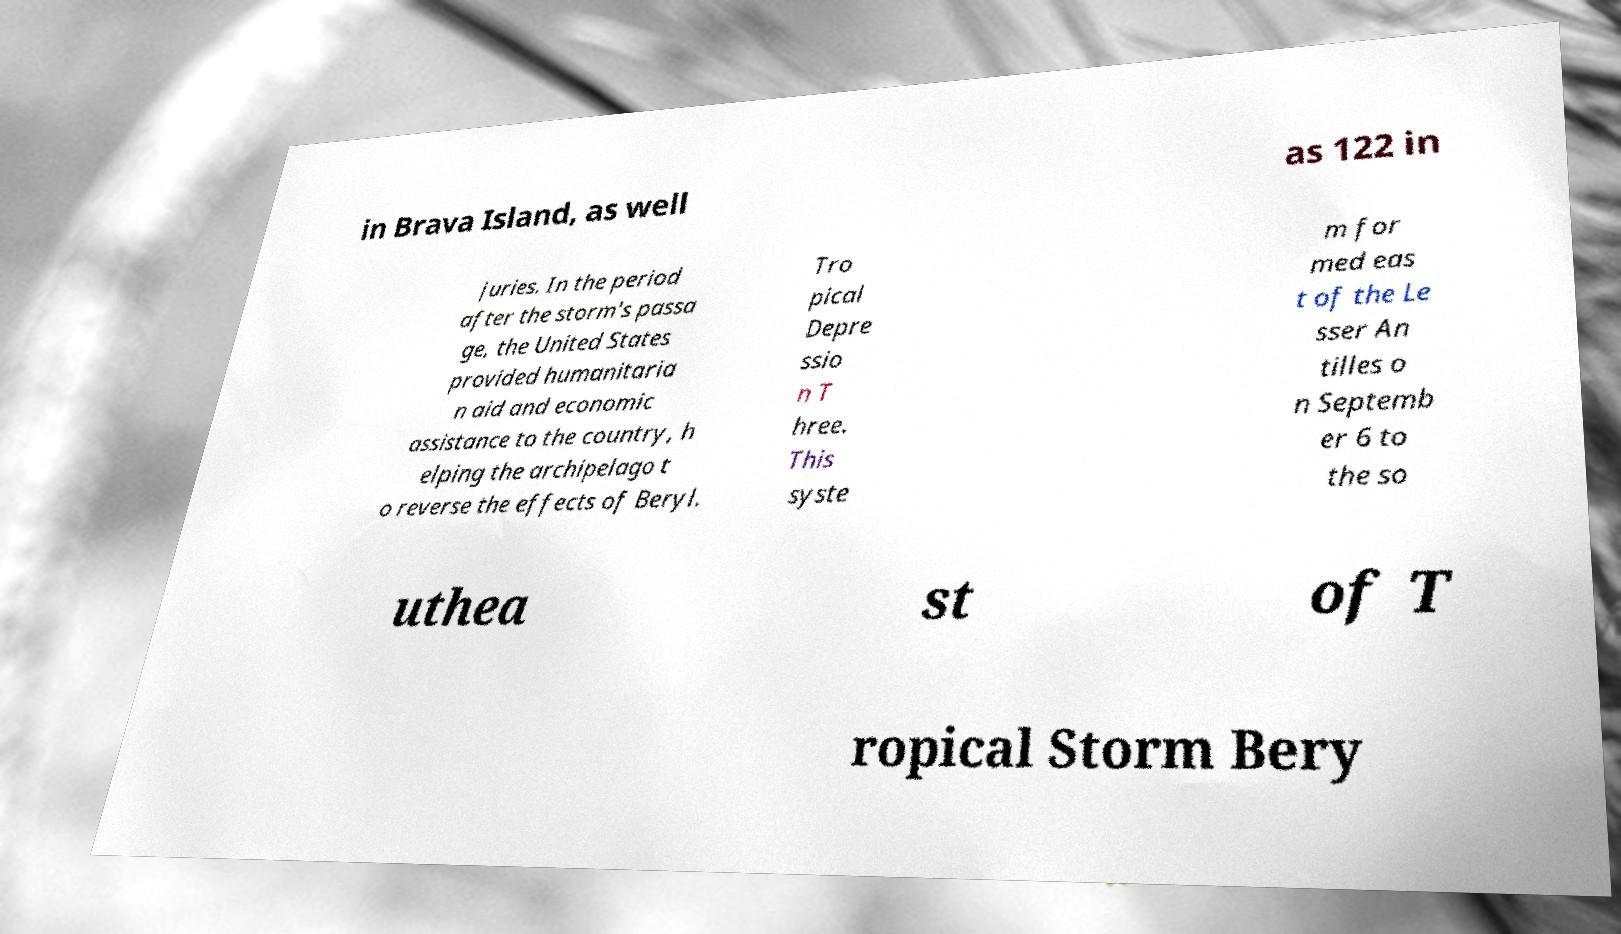Can you read and provide the text displayed in the image?This photo seems to have some interesting text. Can you extract and type it out for me? in Brava Island, as well as 122 in juries. In the period after the storm's passa ge, the United States provided humanitaria n aid and economic assistance to the country, h elping the archipelago t o reverse the effects of Beryl. Tro pical Depre ssio n T hree. This syste m for med eas t of the Le sser An tilles o n Septemb er 6 to the so uthea st of T ropical Storm Bery 